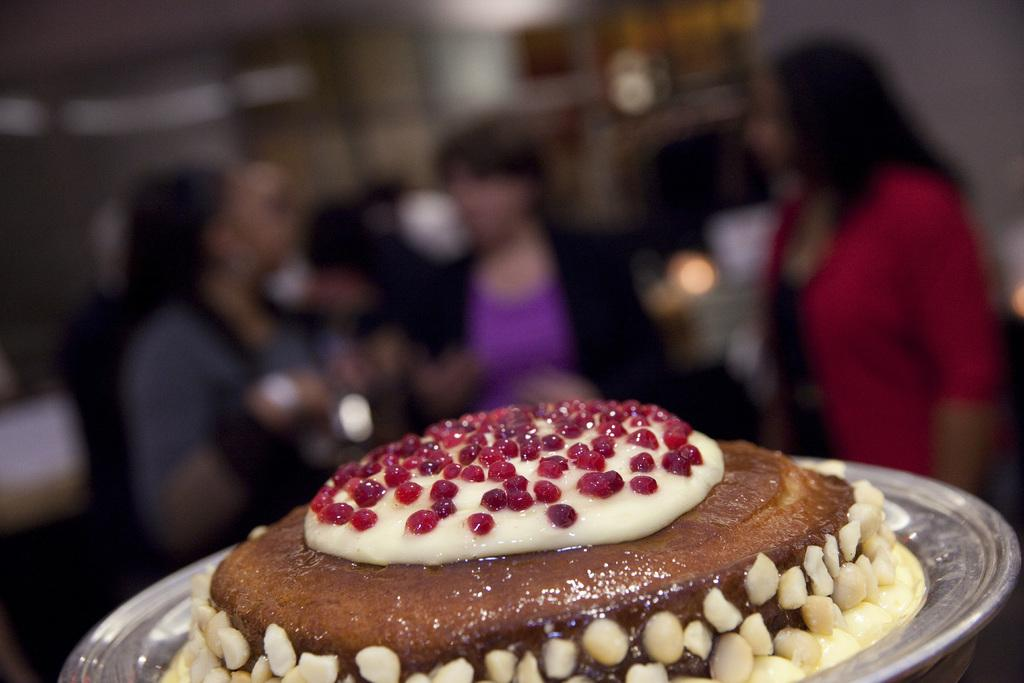What color is the food that is visible in the image? The food is brown-colored. What is the food placed on in the image? The food is on a silver plate. Can you describe the people in the background of the image? There are three women standing in the background of the image. What type of pancake is being served on the silver plate in the image? There is no pancake present in the image; the food is brown-colored and placed on a silver plate. Can you see a tree in the image? There is no tree visible in the image. 